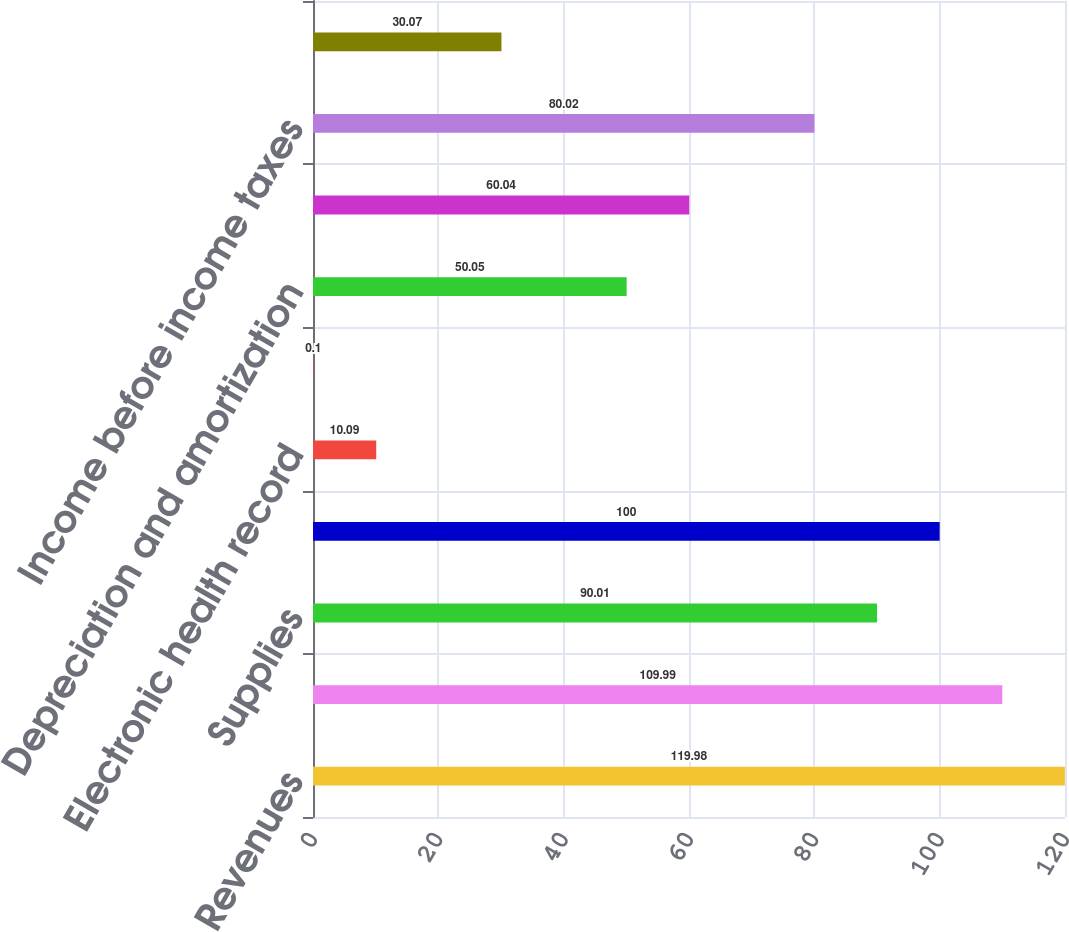Convert chart to OTSL. <chart><loc_0><loc_0><loc_500><loc_500><bar_chart><fcel>Revenues<fcel>Salaries and benefits<fcel>Supplies<fcel>Other operating expenses<fcel>Electronic health record<fcel>Equity in earnings of<fcel>Depreciation and amortization<fcel>Interest expense<fcel>Income before income taxes<fcel>Provision for income taxes<nl><fcel>119.98<fcel>109.99<fcel>90.01<fcel>100<fcel>10.09<fcel>0.1<fcel>50.05<fcel>60.04<fcel>80.02<fcel>30.07<nl></chart> 